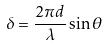Convert formula to latex. <formula><loc_0><loc_0><loc_500><loc_500>\delta = \frac { 2 \pi d } { \lambda } \sin \theta</formula> 